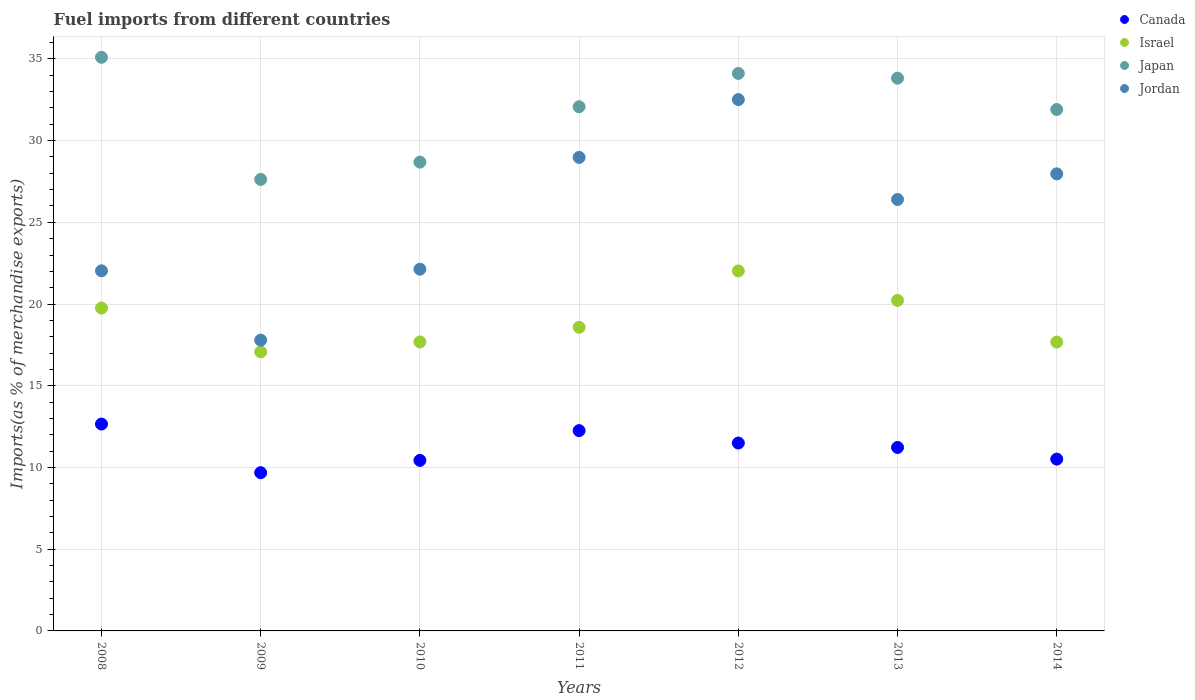How many different coloured dotlines are there?
Ensure brevity in your answer.  4. Is the number of dotlines equal to the number of legend labels?
Give a very brief answer. Yes. What is the percentage of imports to different countries in Japan in 2010?
Offer a very short reply. 28.68. Across all years, what is the maximum percentage of imports to different countries in Jordan?
Offer a terse response. 32.51. Across all years, what is the minimum percentage of imports to different countries in Japan?
Your response must be concise. 27.63. What is the total percentage of imports to different countries in Canada in the graph?
Provide a succinct answer. 78.27. What is the difference between the percentage of imports to different countries in Canada in 2008 and that in 2011?
Offer a terse response. 0.4. What is the difference between the percentage of imports to different countries in Jordan in 2011 and the percentage of imports to different countries in Canada in 2009?
Give a very brief answer. 19.29. What is the average percentage of imports to different countries in Jordan per year?
Your answer should be compact. 25.4. In the year 2012, what is the difference between the percentage of imports to different countries in Canada and percentage of imports to different countries in Israel?
Make the answer very short. -10.53. In how many years, is the percentage of imports to different countries in Canada greater than 23 %?
Provide a short and direct response. 0. What is the ratio of the percentage of imports to different countries in Canada in 2010 to that in 2014?
Provide a short and direct response. 0.99. Is the percentage of imports to different countries in Israel in 2009 less than that in 2013?
Provide a short and direct response. Yes. Is the difference between the percentage of imports to different countries in Canada in 2008 and 2014 greater than the difference between the percentage of imports to different countries in Israel in 2008 and 2014?
Offer a terse response. Yes. What is the difference between the highest and the second highest percentage of imports to different countries in Jordan?
Offer a very short reply. 3.54. What is the difference between the highest and the lowest percentage of imports to different countries in Canada?
Offer a very short reply. 2.97. In how many years, is the percentage of imports to different countries in Japan greater than the average percentage of imports to different countries in Japan taken over all years?
Give a very brief answer. 5. Is it the case that in every year, the sum of the percentage of imports to different countries in Israel and percentage of imports to different countries in Jordan  is greater than the sum of percentage of imports to different countries in Canada and percentage of imports to different countries in Japan?
Your answer should be compact. No. Is it the case that in every year, the sum of the percentage of imports to different countries in Japan and percentage of imports to different countries in Canada  is greater than the percentage of imports to different countries in Israel?
Make the answer very short. Yes. Does the percentage of imports to different countries in Japan monotonically increase over the years?
Make the answer very short. No. How many years are there in the graph?
Your answer should be compact. 7. What is the title of the graph?
Your response must be concise. Fuel imports from different countries. Does "Russian Federation" appear as one of the legend labels in the graph?
Your response must be concise. No. What is the label or title of the X-axis?
Keep it short and to the point. Years. What is the label or title of the Y-axis?
Make the answer very short. Imports(as % of merchandise exports). What is the Imports(as % of merchandise exports) of Canada in 2008?
Provide a succinct answer. 12.66. What is the Imports(as % of merchandise exports) of Israel in 2008?
Provide a succinct answer. 19.76. What is the Imports(as % of merchandise exports) of Japan in 2008?
Offer a very short reply. 35.1. What is the Imports(as % of merchandise exports) in Jordan in 2008?
Give a very brief answer. 22.03. What is the Imports(as % of merchandise exports) in Canada in 2009?
Keep it short and to the point. 9.68. What is the Imports(as % of merchandise exports) of Israel in 2009?
Give a very brief answer. 17.07. What is the Imports(as % of merchandise exports) of Japan in 2009?
Offer a terse response. 27.63. What is the Imports(as % of merchandise exports) in Jordan in 2009?
Your answer should be compact. 17.79. What is the Imports(as % of merchandise exports) in Canada in 2010?
Ensure brevity in your answer.  10.43. What is the Imports(as % of merchandise exports) of Israel in 2010?
Your answer should be very brief. 17.68. What is the Imports(as % of merchandise exports) of Japan in 2010?
Offer a very short reply. 28.68. What is the Imports(as % of merchandise exports) in Jordan in 2010?
Keep it short and to the point. 22.13. What is the Imports(as % of merchandise exports) in Canada in 2011?
Offer a very short reply. 12.26. What is the Imports(as % of merchandise exports) of Israel in 2011?
Make the answer very short. 18.58. What is the Imports(as % of merchandise exports) of Japan in 2011?
Your response must be concise. 32.07. What is the Imports(as % of merchandise exports) in Jordan in 2011?
Your answer should be very brief. 28.97. What is the Imports(as % of merchandise exports) in Canada in 2012?
Provide a short and direct response. 11.5. What is the Imports(as % of merchandise exports) in Israel in 2012?
Your response must be concise. 22.03. What is the Imports(as % of merchandise exports) in Japan in 2012?
Offer a very short reply. 34.11. What is the Imports(as % of merchandise exports) in Jordan in 2012?
Give a very brief answer. 32.51. What is the Imports(as % of merchandise exports) of Canada in 2013?
Keep it short and to the point. 11.23. What is the Imports(as % of merchandise exports) of Israel in 2013?
Your response must be concise. 20.22. What is the Imports(as % of merchandise exports) in Japan in 2013?
Provide a short and direct response. 33.82. What is the Imports(as % of merchandise exports) in Jordan in 2013?
Provide a succinct answer. 26.4. What is the Imports(as % of merchandise exports) of Canada in 2014?
Your answer should be very brief. 10.51. What is the Imports(as % of merchandise exports) of Israel in 2014?
Your response must be concise. 17.67. What is the Imports(as % of merchandise exports) in Japan in 2014?
Provide a short and direct response. 31.9. What is the Imports(as % of merchandise exports) in Jordan in 2014?
Ensure brevity in your answer.  27.97. Across all years, what is the maximum Imports(as % of merchandise exports) of Canada?
Your answer should be compact. 12.66. Across all years, what is the maximum Imports(as % of merchandise exports) of Israel?
Your response must be concise. 22.03. Across all years, what is the maximum Imports(as % of merchandise exports) in Japan?
Offer a very short reply. 35.1. Across all years, what is the maximum Imports(as % of merchandise exports) in Jordan?
Offer a very short reply. 32.51. Across all years, what is the minimum Imports(as % of merchandise exports) of Canada?
Make the answer very short. 9.68. Across all years, what is the minimum Imports(as % of merchandise exports) in Israel?
Offer a very short reply. 17.07. Across all years, what is the minimum Imports(as % of merchandise exports) of Japan?
Provide a succinct answer. 27.63. Across all years, what is the minimum Imports(as % of merchandise exports) of Jordan?
Offer a very short reply. 17.79. What is the total Imports(as % of merchandise exports) in Canada in the graph?
Your response must be concise. 78.27. What is the total Imports(as % of merchandise exports) of Israel in the graph?
Ensure brevity in your answer.  133.02. What is the total Imports(as % of merchandise exports) of Japan in the graph?
Provide a succinct answer. 223.31. What is the total Imports(as % of merchandise exports) in Jordan in the graph?
Keep it short and to the point. 177.81. What is the difference between the Imports(as % of merchandise exports) of Canada in 2008 and that in 2009?
Make the answer very short. 2.97. What is the difference between the Imports(as % of merchandise exports) of Israel in 2008 and that in 2009?
Provide a succinct answer. 2.68. What is the difference between the Imports(as % of merchandise exports) in Japan in 2008 and that in 2009?
Keep it short and to the point. 7.47. What is the difference between the Imports(as % of merchandise exports) in Jordan in 2008 and that in 2009?
Keep it short and to the point. 4.24. What is the difference between the Imports(as % of merchandise exports) in Canada in 2008 and that in 2010?
Offer a terse response. 2.22. What is the difference between the Imports(as % of merchandise exports) in Israel in 2008 and that in 2010?
Make the answer very short. 2.07. What is the difference between the Imports(as % of merchandise exports) in Japan in 2008 and that in 2010?
Offer a very short reply. 6.41. What is the difference between the Imports(as % of merchandise exports) in Jordan in 2008 and that in 2010?
Provide a short and direct response. -0.1. What is the difference between the Imports(as % of merchandise exports) of Canada in 2008 and that in 2011?
Ensure brevity in your answer.  0.4. What is the difference between the Imports(as % of merchandise exports) of Israel in 2008 and that in 2011?
Your response must be concise. 1.18. What is the difference between the Imports(as % of merchandise exports) of Japan in 2008 and that in 2011?
Offer a terse response. 3.02. What is the difference between the Imports(as % of merchandise exports) in Jordan in 2008 and that in 2011?
Your answer should be compact. -6.94. What is the difference between the Imports(as % of merchandise exports) of Canada in 2008 and that in 2012?
Keep it short and to the point. 1.16. What is the difference between the Imports(as % of merchandise exports) in Israel in 2008 and that in 2012?
Give a very brief answer. -2.27. What is the difference between the Imports(as % of merchandise exports) of Japan in 2008 and that in 2012?
Provide a short and direct response. 0.98. What is the difference between the Imports(as % of merchandise exports) of Jordan in 2008 and that in 2012?
Give a very brief answer. -10.48. What is the difference between the Imports(as % of merchandise exports) in Canada in 2008 and that in 2013?
Make the answer very short. 1.43. What is the difference between the Imports(as % of merchandise exports) of Israel in 2008 and that in 2013?
Offer a very short reply. -0.47. What is the difference between the Imports(as % of merchandise exports) in Japan in 2008 and that in 2013?
Offer a terse response. 1.27. What is the difference between the Imports(as % of merchandise exports) of Jordan in 2008 and that in 2013?
Make the answer very short. -4.36. What is the difference between the Imports(as % of merchandise exports) of Canada in 2008 and that in 2014?
Ensure brevity in your answer.  2.14. What is the difference between the Imports(as % of merchandise exports) of Israel in 2008 and that in 2014?
Your answer should be very brief. 2.08. What is the difference between the Imports(as % of merchandise exports) in Japan in 2008 and that in 2014?
Provide a short and direct response. 3.19. What is the difference between the Imports(as % of merchandise exports) of Jordan in 2008 and that in 2014?
Provide a succinct answer. -5.93. What is the difference between the Imports(as % of merchandise exports) in Canada in 2009 and that in 2010?
Provide a succinct answer. -0.75. What is the difference between the Imports(as % of merchandise exports) of Israel in 2009 and that in 2010?
Offer a very short reply. -0.61. What is the difference between the Imports(as % of merchandise exports) in Japan in 2009 and that in 2010?
Your answer should be very brief. -1.06. What is the difference between the Imports(as % of merchandise exports) of Jordan in 2009 and that in 2010?
Make the answer very short. -4.34. What is the difference between the Imports(as % of merchandise exports) of Canada in 2009 and that in 2011?
Give a very brief answer. -2.57. What is the difference between the Imports(as % of merchandise exports) in Israel in 2009 and that in 2011?
Offer a terse response. -1.5. What is the difference between the Imports(as % of merchandise exports) of Japan in 2009 and that in 2011?
Offer a terse response. -4.45. What is the difference between the Imports(as % of merchandise exports) of Jordan in 2009 and that in 2011?
Your answer should be compact. -11.18. What is the difference between the Imports(as % of merchandise exports) of Canada in 2009 and that in 2012?
Provide a short and direct response. -1.81. What is the difference between the Imports(as % of merchandise exports) of Israel in 2009 and that in 2012?
Your response must be concise. -4.95. What is the difference between the Imports(as % of merchandise exports) of Japan in 2009 and that in 2012?
Your response must be concise. -6.49. What is the difference between the Imports(as % of merchandise exports) of Jordan in 2009 and that in 2012?
Give a very brief answer. -14.72. What is the difference between the Imports(as % of merchandise exports) in Canada in 2009 and that in 2013?
Keep it short and to the point. -1.54. What is the difference between the Imports(as % of merchandise exports) in Israel in 2009 and that in 2013?
Offer a very short reply. -3.15. What is the difference between the Imports(as % of merchandise exports) in Japan in 2009 and that in 2013?
Your answer should be compact. -6.2. What is the difference between the Imports(as % of merchandise exports) in Jordan in 2009 and that in 2013?
Ensure brevity in your answer.  -8.61. What is the difference between the Imports(as % of merchandise exports) in Canada in 2009 and that in 2014?
Make the answer very short. -0.83. What is the difference between the Imports(as % of merchandise exports) of Japan in 2009 and that in 2014?
Offer a terse response. -4.28. What is the difference between the Imports(as % of merchandise exports) of Jordan in 2009 and that in 2014?
Provide a short and direct response. -10.17. What is the difference between the Imports(as % of merchandise exports) of Canada in 2010 and that in 2011?
Provide a short and direct response. -1.82. What is the difference between the Imports(as % of merchandise exports) in Israel in 2010 and that in 2011?
Your response must be concise. -0.9. What is the difference between the Imports(as % of merchandise exports) in Japan in 2010 and that in 2011?
Keep it short and to the point. -3.39. What is the difference between the Imports(as % of merchandise exports) of Jordan in 2010 and that in 2011?
Give a very brief answer. -6.84. What is the difference between the Imports(as % of merchandise exports) in Canada in 2010 and that in 2012?
Provide a short and direct response. -1.06. What is the difference between the Imports(as % of merchandise exports) of Israel in 2010 and that in 2012?
Make the answer very short. -4.34. What is the difference between the Imports(as % of merchandise exports) in Japan in 2010 and that in 2012?
Provide a succinct answer. -5.43. What is the difference between the Imports(as % of merchandise exports) of Jordan in 2010 and that in 2012?
Your answer should be very brief. -10.38. What is the difference between the Imports(as % of merchandise exports) of Canada in 2010 and that in 2013?
Provide a short and direct response. -0.79. What is the difference between the Imports(as % of merchandise exports) in Israel in 2010 and that in 2013?
Your response must be concise. -2.54. What is the difference between the Imports(as % of merchandise exports) in Japan in 2010 and that in 2013?
Offer a very short reply. -5.14. What is the difference between the Imports(as % of merchandise exports) in Jordan in 2010 and that in 2013?
Your answer should be very brief. -4.27. What is the difference between the Imports(as % of merchandise exports) of Canada in 2010 and that in 2014?
Offer a terse response. -0.08. What is the difference between the Imports(as % of merchandise exports) in Israel in 2010 and that in 2014?
Make the answer very short. 0.01. What is the difference between the Imports(as % of merchandise exports) in Japan in 2010 and that in 2014?
Offer a very short reply. -3.22. What is the difference between the Imports(as % of merchandise exports) of Jordan in 2010 and that in 2014?
Make the answer very short. -5.83. What is the difference between the Imports(as % of merchandise exports) of Canada in 2011 and that in 2012?
Your response must be concise. 0.76. What is the difference between the Imports(as % of merchandise exports) in Israel in 2011 and that in 2012?
Provide a short and direct response. -3.45. What is the difference between the Imports(as % of merchandise exports) in Japan in 2011 and that in 2012?
Your response must be concise. -2.04. What is the difference between the Imports(as % of merchandise exports) of Jordan in 2011 and that in 2012?
Ensure brevity in your answer.  -3.54. What is the difference between the Imports(as % of merchandise exports) in Canada in 2011 and that in 2013?
Give a very brief answer. 1.03. What is the difference between the Imports(as % of merchandise exports) of Israel in 2011 and that in 2013?
Give a very brief answer. -1.64. What is the difference between the Imports(as % of merchandise exports) in Japan in 2011 and that in 2013?
Keep it short and to the point. -1.75. What is the difference between the Imports(as % of merchandise exports) of Jordan in 2011 and that in 2013?
Offer a very short reply. 2.57. What is the difference between the Imports(as % of merchandise exports) in Canada in 2011 and that in 2014?
Keep it short and to the point. 1.74. What is the difference between the Imports(as % of merchandise exports) in Israel in 2011 and that in 2014?
Your answer should be very brief. 0.9. What is the difference between the Imports(as % of merchandise exports) of Japan in 2011 and that in 2014?
Keep it short and to the point. 0.17. What is the difference between the Imports(as % of merchandise exports) in Jordan in 2011 and that in 2014?
Ensure brevity in your answer.  1.01. What is the difference between the Imports(as % of merchandise exports) of Canada in 2012 and that in 2013?
Your answer should be very brief. 0.27. What is the difference between the Imports(as % of merchandise exports) in Israel in 2012 and that in 2013?
Provide a succinct answer. 1.8. What is the difference between the Imports(as % of merchandise exports) in Japan in 2012 and that in 2013?
Ensure brevity in your answer.  0.29. What is the difference between the Imports(as % of merchandise exports) in Jordan in 2012 and that in 2013?
Your response must be concise. 6.11. What is the difference between the Imports(as % of merchandise exports) of Canada in 2012 and that in 2014?
Make the answer very short. 0.98. What is the difference between the Imports(as % of merchandise exports) of Israel in 2012 and that in 2014?
Offer a terse response. 4.35. What is the difference between the Imports(as % of merchandise exports) in Japan in 2012 and that in 2014?
Provide a short and direct response. 2.21. What is the difference between the Imports(as % of merchandise exports) in Jordan in 2012 and that in 2014?
Keep it short and to the point. 4.55. What is the difference between the Imports(as % of merchandise exports) in Canada in 2013 and that in 2014?
Offer a very short reply. 0.71. What is the difference between the Imports(as % of merchandise exports) in Israel in 2013 and that in 2014?
Give a very brief answer. 2.55. What is the difference between the Imports(as % of merchandise exports) in Japan in 2013 and that in 2014?
Ensure brevity in your answer.  1.92. What is the difference between the Imports(as % of merchandise exports) in Jordan in 2013 and that in 2014?
Provide a short and direct response. -1.57. What is the difference between the Imports(as % of merchandise exports) of Canada in 2008 and the Imports(as % of merchandise exports) of Israel in 2009?
Provide a short and direct response. -4.42. What is the difference between the Imports(as % of merchandise exports) in Canada in 2008 and the Imports(as % of merchandise exports) in Japan in 2009?
Your answer should be compact. -14.97. What is the difference between the Imports(as % of merchandise exports) of Canada in 2008 and the Imports(as % of merchandise exports) of Jordan in 2009?
Your answer should be compact. -5.14. What is the difference between the Imports(as % of merchandise exports) in Israel in 2008 and the Imports(as % of merchandise exports) in Japan in 2009?
Provide a short and direct response. -7.87. What is the difference between the Imports(as % of merchandise exports) of Israel in 2008 and the Imports(as % of merchandise exports) of Jordan in 2009?
Your answer should be compact. 1.96. What is the difference between the Imports(as % of merchandise exports) of Japan in 2008 and the Imports(as % of merchandise exports) of Jordan in 2009?
Your answer should be very brief. 17.3. What is the difference between the Imports(as % of merchandise exports) of Canada in 2008 and the Imports(as % of merchandise exports) of Israel in 2010?
Offer a terse response. -5.02. What is the difference between the Imports(as % of merchandise exports) of Canada in 2008 and the Imports(as % of merchandise exports) of Japan in 2010?
Offer a very short reply. -16.03. What is the difference between the Imports(as % of merchandise exports) in Canada in 2008 and the Imports(as % of merchandise exports) in Jordan in 2010?
Make the answer very short. -9.48. What is the difference between the Imports(as % of merchandise exports) of Israel in 2008 and the Imports(as % of merchandise exports) of Japan in 2010?
Provide a short and direct response. -8.93. What is the difference between the Imports(as % of merchandise exports) in Israel in 2008 and the Imports(as % of merchandise exports) in Jordan in 2010?
Your answer should be compact. -2.38. What is the difference between the Imports(as % of merchandise exports) of Japan in 2008 and the Imports(as % of merchandise exports) of Jordan in 2010?
Your answer should be compact. 12.96. What is the difference between the Imports(as % of merchandise exports) of Canada in 2008 and the Imports(as % of merchandise exports) of Israel in 2011?
Give a very brief answer. -5.92. What is the difference between the Imports(as % of merchandise exports) of Canada in 2008 and the Imports(as % of merchandise exports) of Japan in 2011?
Provide a short and direct response. -19.42. What is the difference between the Imports(as % of merchandise exports) in Canada in 2008 and the Imports(as % of merchandise exports) in Jordan in 2011?
Offer a terse response. -16.31. What is the difference between the Imports(as % of merchandise exports) of Israel in 2008 and the Imports(as % of merchandise exports) of Japan in 2011?
Your response must be concise. -12.32. What is the difference between the Imports(as % of merchandise exports) of Israel in 2008 and the Imports(as % of merchandise exports) of Jordan in 2011?
Make the answer very short. -9.22. What is the difference between the Imports(as % of merchandise exports) in Japan in 2008 and the Imports(as % of merchandise exports) in Jordan in 2011?
Your answer should be very brief. 6.12. What is the difference between the Imports(as % of merchandise exports) of Canada in 2008 and the Imports(as % of merchandise exports) of Israel in 2012?
Ensure brevity in your answer.  -9.37. What is the difference between the Imports(as % of merchandise exports) of Canada in 2008 and the Imports(as % of merchandise exports) of Japan in 2012?
Give a very brief answer. -21.45. What is the difference between the Imports(as % of merchandise exports) in Canada in 2008 and the Imports(as % of merchandise exports) in Jordan in 2012?
Give a very brief answer. -19.85. What is the difference between the Imports(as % of merchandise exports) of Israel in 2008 and the Imports(as % of merchandise exports) of Japan in 2012?
Offer a terse response. -14.36. What is the difference between the Imports(as % of merchandise exports) in Israel in 2008 and the Imports(as % of merchandise exports) in Jordan in 2012?
Offer a very short reply. -12.76. What is the difference between the Imports(as % of merchandise exports) in Japan in 2008 and the Imports(as % of merchandise exports) in Jordan in 2012?
Offer a very short reply. 2.58. What is the difference between the Imports(as % of merchandise exports) in Canada in 2008 and the Imports(as % of merchandise exports) in Israel in 2013?
Your answer should be compact. -7.57. What is the difference between the Imports(as % of merchandise exports) of Canada in 2008 and the Imports(as % of merchandise exports) of Japan in 2013?
Give a very brief answer. -21.16. What is the difference between the Imports(as % of merchandise exports) of Canada in 2008 and the Imports(as % of merchandise exports) of Jordan in 2013?
Provide a succinct answer. -13.74. What is the difference between the Imports(as % of merchandise exports) in Israel in 2008 and the Imports(as % of merchandise exports) in Japan in 2013?
Make the answer very short. -14.07. What is the difference between the Imports(as % of merchandise exports) in Israel in 2008 and the Imports(as % of merchandise exports) in Jordan in 2013?
Your answer should be very brief. -6.64. What is the difference between the Imports(as % of merchandise exports) in Japan in 2008 and the Imports(as % of merchandise exports) in Jordan in 2013?
Make the answer very short. 8.7. What is the difference between the Imports(as % of merchandise exports) of Canada in 2008 and the Imports(as % of merchandise exports) of Israel in 2014?
Keep it short and to the point. -5.02. What is the difference between the Imports(as % of merchandise exports) of Canada in 2008 and the Imports(as % of merchandise exports) of Japan in 2014?
Make the answer very short. -19.25. What is the difference between the Imports(as % of merchandise exports) in Canada in 2008 and the Imports(as % of merchandise exports) in Jordan in 2014?
Make the answer very short. -15.31. What is the difference between the Imports(as % of merchandise exports) of Israel in 2008 and the Imports(as % of merchandise exports) of Japan in 2014?
Offer a terse response. -12.15. What is the difference between the Imports(as % of merchandise exports) in Israel in 2008 and the Imports(as % of merchandise exports) in Jordan in 2014?
Your answer should be very brief. -8.21. What is the difference between the Imports(as % of merchandise exports) in Japan in 2008 and the Imports(as % of merchandise exports) in Jordan in 2014?
Give a very brief answer. 7.13. What is the difference between the Imports(as % of merchandise exports) in Canada in 2009 and the Imports(as % of merchandise exports) in Israel in 2010?
Your answer should be compact. -8. What is the difference between the Imports(as % of merchandise exports) of Canada in 2009 and the Imports(as % of merchandise exports) of Japan in 2010?
Offer a terse response. -19. What is the difference between the Imports(as % of merchandise exports) of Canada in 2009 and the Imports(as % of merchandise exports) of Jordan in 2010?
Give a very brief answer. -12.45. What is the difference between the Imports(as % of merchandise exports) of Israel in 2009 and the Imports(as % of merchandise exports) of Japan in 2010?
Your response must be concise. -11.61. What is the difference between the Imports(as % of merchandise exports) of Israel in 2009 and the Imports(as % of merchandise exports) of Jordan in 2010?
Your answer should be very brief. -5.06. What is the difference between the Imports(as % of merchandise exports) of Japan in 2009 and the Imports(as % of merchandise exports) of Jordan in 2010?
Provide a short and direct response. 5.49. What is the difference between the Imports(as % of merchandise exports) in Canada in 2009 and the Imports(as % of merchandise exports) in Israel in 2011?
Provide a succinct answer. -8.9. What is the difference between the Imports(as % of merchandise exports) in Canada in 2009 and the Imports(as % of merchandise exports) in Japan in 2011?
Offer a terse response. -22.39. What is the difference between the Imports(as % of merchandise exports) in Canada in 2009 and the Imports(as % of merchandise exports) in Jordan in 2011?
Your answer should be very brief. -19.29. What is the difference between the Imports(as % of merchandise exports) in Israel in 2009 and the Imports(as % of merchandise exports) in Japan in 2011?
Your response must be concise. -15. What is the difference between the Imports(as % of merchandise exports) of Israel in 2009 and the Imports(as % of merchandise exports) of Jordan in 2011?
Give a very brief answer. -11.9. What is the difference between the Imports(as % of merchandise exports) in Japan in 2009 and the Imports(as % of merchandise exports) in Jordan in 2011?
Ensure brevity in your answer.  -1.35. What is the difference between the Imports(as % of merchandise exports) in Canada in 2009 and the Imports(as % of merchandise exports) in Israel in 2012?
Keep it short and to the point. -12.34. What is the difference between the Imports(as % of merchandise exports) of Canada in 2009 and the Imports(as % of merchandise exports) of Japan in 2012?
Your answer should be very brief. -24.43. What is the difference between the Imports(as % of merchandise exports) of Canada in 2009 and the Imports(as % of merchandise exports) of Jordan in 2012?
Provide a succinct answer. -22.83. What is the difference between the Imports(as % of merchandise exports) in Israel in 2009 and the Imports(as % of merchandise exports) in Japan in 2012?
Provide a short and direct response. -17.04. What is the difference between the Imports(as % of merchandise exports) in Israel in 2009 and the Imports(as % of merchandise exports) in Jordan in 2012?
Offer a very short reply. -15.44. What is the difference between the Imports(as % of merchandise exports) of Japan in 2009 and the Imports(as % of merchandise exports) of Jordan in 2012?
Your response must be concise. -4.89. What is the difference between the Imports(as % of merchandise exports) in Canada in 2009 and the Imports(as % of merchandise exports) in Israel in 2013?
Your answer should be very brief. -10.54. What is the difference between the Imports(as % of merchandise exports) in Canada in 2009 and the Imports(as % of merchandise exports) in Japan in 2013?
Make the answer very short. -24.14. What is the difference between the Imports(as % of merchandise exports) in Canada in 2009 and the Imports(as % of merchandise exports) in Jordan in 2013?
Offer a very short reply. -16.72. What is the difference between the Imports(as % of merchandise exports) in Israel in 2009 and the Imports(as % of merchandise exports) in Japan in 2013?
Give a very brief answer. -16.75. What is the difference between the Imports(as % of merchandise exports) of Israel in 2009 and the Imports(as % of merchandise exports) of Jordan in 2013?
Provide a short and direct response. -9.32. What is the difference between the Imports(as % of merchandise exports) of Japan in 2009 and the Imports(as % of merchandise exports) of Jordan in 2013?
Your answer should be compact. 1.23. What is the difference between the Imports(as % of merchandise exports) of Canada in 2009 and the Imports(as % of merchandise exports) of Israel in 2014?
Give a very brief answer. -7.99. What is the difference between the Imports(as % of merchandise exports) of Canada in 2009 and the Imports(as % of merchandise exports) of Japan in 2014?
Provide a succinct answer. -22.22. What is the difference between the Imports(as % of merchandise exports) of Canada in 2009 and the Imports(as % of merchandise exports) of Jordan in 2014?
Make the answer very short. -18.28. What is the difference between the Imports(as % of merchandise exports) in Israel in 2009 and the Imports(as % of merchandise exports) in Japan in 2014?
Offer a very short reply. -14.83. What is the difference between the Imports(as % of merchandise exports) of Israel in 2009 and the Imports(as % of merchandise exports) of Jordan in 2014?
Offer a very short reply. -10.89. What is the difference between the Imports(as % of merchandise exports) in Japan in 2009 and the Imports(as % of merchandise exports) in Jordan in 2014?
Give a very brief answer. -0.34. What is the difference between the Imports(as % of merchandise exports) in Canada in 2010 and the Imports(as % of merchandise exports) in Israel in 2011?
Your answer should be compact. -8.14. What is the difference between the Imports(as % of merchandise exports) of Canada in 2010 and the Imports(as % of merchandise exports) of Japan in 2011?
Keep it short and to the point. -21.64. What is the difference between the Imports(as % of merchandise exports) of Canada in 2010 and the Imports(as % of merchandise exports) of Jordan in 2011?
Offer a terse response. -18.54. What is the difference between the Imports(as % of merchandise exports) in Israel in 2010 and the Imports(as % of merchandise exports) in Japan in 2011?
Your answer should be very brief. -14.39. What is the difference between the Imports(as % of merchandise exports) in Israel in 2010 and the Imports(as % of merchandise exports) in Jordan in 2011?
Provide a succinct answer. -11.29. What is the difference between the Imports(as % of merchandise exports) of Japan in 2010 and the Imports(as % of merchandise exports) of Jordan in 2011?
Your answer should be compact. -0.29. What is the difference between the Imports(as % of merchandise exports) in Canada in 2010 and the Imports(as % of merchandise exports) in Israel in 2012?
Offer a terse response. -11.59. What is the difference between the Imports(as % of merchandise exports) in Canada in 2010 and the Imports(as % of merchandise exports) in Japan in 2012?
Your answer should be compact. -23.68. What is the difference between the Imports(as % of merchandise exports) in Canada in 2010 and the Imports(as % of merchandise exports) in Jordan in 2012?
Your answer should be compact. -22.08. What is the difference between the Imports(as % of merchandise exports) of Israel in 2010 and the Imports(as % of merchandise exports) of Japan in 2012?
Offer a terse response. -16.43. What is the difference between the Imports(as % of merchandise exports) of Israel in 2010 and the Imports(as % of merchandise exports) of Jordan in 2012?
Offer a terse response. -14.83. What is the difference between the Imports(as % of merchandise exports) of Japan in 2010 and the Imports(as % of merchandise exports) of Jordan in 2012?
Offer a terse response. -3.83. What is the difference between the Imports(as % of merchandise exports) of Canada in 2010 and the Imports(as % of merchandise exports) of Israel in 2013?
Give a very brief answer. -9.79. What is the difference between the Imports(as % of merchandise exports) of Canada in 2010 and the Imports(as % of merchandise exports) of Japan in 2013?
Give a very brief answer. -23.39. What is the difference between the Imports(as % of merchandise exports) in Canada in 2010 and the Imports(as % of merchandise exports) in Jordan in 2013?
Your answer should be very brief. -15.96. What is the difference between the Imports(as % of merchandise exports) in Israel in 2010 and the Imports(as % of merchandise exports) in Japan in 2013?
Your response must be concise. -16.14. What is the difference between the Imports(as % of merchandise exports) of Israel in 2010 and the Imports(as % of merchandise exports) of Jordan in 2013?
Provide a short and direct response. -8.72. What is the difference between the Imports(as % of merchandise exports) of Japan in 2010 and the Imports(as % of merchandise exports) of Jordan in 2013?
Make the answer very short. 2.29. What is the difference between the Imports(as % of merchandise exports) of Canada in 2010 and the Imports(as % of merchandise exports) of Israel in 2014?
Provide a short and direct response. -7.24. What is the difference between the Imports(as % of merchandise exports) in Canada in 2010 and the Imports(as % of merchandise exports) in Japan in 2014?
Offer a very short reply. -21.47. What is the difference between the Imports(as % of merchandise exports) of Canada in 2010 and the Imports(as % of merchandise exports) of Jordan in 2014?
Your answer should be very brief. -17.53. What is the difference between the Imports(as % of merchandise exports) of Israel in 2010 and the Imports(as % of merchandise exports) of Japan in 2014?
Give a very brief answer. -14.22. What is the difference between the Imports(as % of merchandise exports) in Israel in 2010 and the Imports(as % of merchandise exports) in Jordan in 2014?
Provide a succinct answer. -10.28. What is the difference between the Imports(as % of merchandise exports) in Japan in 2010 and the Imports(as % of merchandise exports) in Jordan in 2014?
Provide a succinct answer. 0.72. What is the difference between the Imports(as % of merchandise exports) in Canada in 2011 and the Imports(as % of merchandise exports) in Israel in 2012?
Provide a short and direct response. -9.77. What is the difference between the Imports(as % of merchandise exports) of Canada in 2011 and the Imports(as % of merchandise exports) of Japan in 2012?
Provide a succinct answer. -21.86. What is the difference between the Imports(as % of merchandise exports) of Canada in 2011 and the Imports(as % of merchandise exports) of Jordan in 2012?
Provide a short and direct response. -20.26. What is the difference between the Imports(as % of merchandise exports) in Israel in 2011 and the Imports(as % of merchandise exports) in Japan in 2012?
Offer a terse response. -15.53. What is the difference between the Imports(as % of merchandise exports) in Israel in 2011 and the Imports(as % of merchandise exports) in Jordan in 2012?
Offer a terse response. -13.93. What is the difference between the Imports(as % of merchandise exports) of Japan in 2011 and the Imports(as % of merchandise exports) of Jordan in 2012?
Keep it short and to the point. -0.44. What is the difference between the Imports(as % of merchandise exports) in Canada in 2011 and the Imports(as % of merchandise exports) in Israel in 2013?
Make the answer very short. -7.97. What is the difference between the Imports(as % of merchandise exports) of Canada in 2011 and the Imports(as % of merchandise exports) of Japan in 2013?
Your answer should be very brief. -21.57. What is the difference between the Imports(as % of merchandise exports) in Canada in 2011 and the Imports(as % of merchandise exports) in Jordan in 2013?
Provide a succinct answer. -14.14. What is the difference between the Imports(as % of merchandise exports) of Israel in 2011 and the Imports(as % of merchandise exports) of Japan in 2013?
Make the answer very short. -15.24. What is the difference between the Imports(as % of merchandise exports) of Israel in 2011 and the Imports(as % of merchandise exports) of Jordan in 2013?
Your answer should be very brief. -7.82. What is the difference between the Imports(as % of merchandise exports) in Japan in 2011 and the Imports(as % of merchandise exports) in Jordan in 2013?
Provide a succinct answer. 5.68. What is the difference between the Imports(as % of merchandise exports) in Canada in 2011 and the Imports(as % of merchandise exports) in Israel in 2014?
Provide a short and direct response. -5.42. What is the difference between the Imports(as % of merchandise exports) in Canada in 2011 and the Imports(as % of merchandise exports) in Japan in 2014?
Your answer should be compact. -19.65. What is the difference between the Imports(as % of merchandise exports) in Canada in 2011 and the Imports(as % of merchandise exports) in Jordan in 2014?
Offer a very short reply. -15.71. What is the difference between the Imports(as % of merchandise exports) in Israel in 2011 and the Imports(as % of merchandise exports) in Japan in 2014?
Your response must be concise. -13.32. What is the difference between the Imports(as % of merchandise exports) of Israel in 2011 and the Imports(as % of merchandise exports) of Jordan in 2014?
Offer a terse response. -9.39. What is the difference between the Imports(as % of merchandise exports) of Japan in 2011 and the Imports(as % of merchandise exports) of Jordan in 2014?
Keep it short and to the point. 4.11. What is the difference between the Imports(as % of merchandise exports) of Canada in 2012 and the Imports(as % of merchandise exports) of Israel in 2013?
Your answer should be very brief. -8.73. What is the difference between the Imports(as % of merchandise exports) of Canada in 2012 and the Imports(as % of merchandise exports) of Japan in 2013?
Keep it short and to the point. -22.33. What is the difference between the Imports(as % of merchandise exports) in Canada in 2012 and the Imports(as % of merchandise exports) in Jordan in 2013?
Your response must be concise. -14.9. What is the difference between the Imports(as % of merchandise exports) in Israel in 2012 and the Imports(as % of merchandise exports) in Japan in 2013?
Ensure brevity in your answer.  -11.79. What is the difference between the Imports(as % of merchandise exports) in Israel in 2012 and the Imports(as % of merchandise exports) in Jordan in 2013?
Your answer should be very brief. -4.37. What is the difference between the Imports(as % of merchandise exports) of Japan in 2012 and the Imports(as % of merchandise exports) of Jordan in 2013?
Ensure brevity in your answer.  7.71. What is the difference between the Imports(as % of merchandise exports) in Canada in 2012 and the Imports(as % of merchandise exports) in Israel in 2014?
Provide a short and direct response. -6.18. What is the difference between the Imports(as % of merchandise exports) in Canada in 2012 and the Imports(as % of merchandise exports) in Japan in 2014?
Offer a very short reply. -20.41. What is the difference between the Imports(as % of merchandise exports) of Canada in 2012 and the Imports(as % of merchandise exports) of Jordan in 2014?
Your answer should be compact. -16.47. What is the difference between the Imports(as % of merchandise exports) of Israel in 2012 and the Imports(as % of merchandise exports) of Japan in 2014?
Offer a terse response. -9.88. What is the difference between the Imports(as % of merchandise exports) of Israel in 2012 and the Imports(as % of merchandise exports) of Jordan in 2014?
Offer a terse response. -5.94. What is the difference between the Imports(as % of merchandise exports) in Japan in 2012 and the Imports(as % of merchandise exports) in Jordan in 2014?
Offer a terse response. 6.14. What is the difference between the Imports(as % of merchandise exports) in Canada in 2013 and the Imports(as % of merchandise exports) in Israel in 2014?
Offer a terse response. -6.45. What is the difference between the Imports(as % of merchandise exports) in Canada in 2013 and the Imports(as % of merchandise exports) in Japan in 2014?
Offer a very short reply. -20.68. What is the difference between the Imports(as % of merchandise exports) in Canada in 2013 and the Imports(as % of merchandise exports) in Jordan in 2014?
Offer a terse response. -16.74. What is the difference between the Imports(as % of merchandise exports) in Israel in 2013 and the Imports(as % of merchandise exports) in Japan in 2014?
Give a very brief answer. -11.68. What is the difference between the Imports(as % of merchandise exports) of Israel in 2013 and the Imports(as % of merchandise exports) of Jordan in 2014?
Offer a terse response. -7.74. What is the difference between the Imports(as % of merchandise exports) in Japan in 2013 and the Imports(as % of merchandise exports) in Jordan in 2014?
Make the answer very short. 5.85. What is the average Imports(as % of merchandise exports) in Canada per year?
Make the answer very short. 11.18. What is the average Imports(as % of merchandise exports) of Israel per year?
Offer a very short reply. 19. What is the average Imports(as % of merchandise exports) in Japan per year?
Give a very brief answer. 31.9. What is the average Imports(as % of merchandise exports) in Jordan per year?
Give a very brief answer. 25.4. In the year 2008, what is the difference between the Imports(as % of merchandise exports) of Canada and Imports(as % of merchandise exports) of Israel?
Offer a very short reply. -7.1. In the year 2008, what is the difference between the Imports(as % of merchandise exports) in Canada and Imports(as % of merchandise exports) in Japan?
Ensure brevity in your answer.  -22.44. In the year 2008, what is the difference between the Imports(as % of merchandise exports) of Canada and Imports(as % of merchandise exports) of Jordan?
Offer a terse response. -9.38. In the year 2008, what is the difference between the Imports(as % of merchandise exports) in Israel and Imports(as % of merchandise exports) in Japan?
Ensure brevity in your answer.  -15.34. In the year 2008, what is the difference between the Imports(as % of merchandise exports) in Israel and Imports(as % of merchandise exports) in Jordan?
Keep it short and to the point. -2.28. In the year 2008, what is the difference between the Imports(as % of merchandise exports) of Japan and Imports(as % of merchandise exports) of Jordan?
Your answer should be very brief. 13.06. In the year 2009, what is the difference between the Imports(as % of merchandise exports) in Canada and Imports(as % of merchandise exports) in Israel?
Provide a short and direct response. -7.39. In the year 2009, what is the difference between the Imports(as % of merchandise exports) in Canada and Imports(as % of merchandise exports) in Japan?
Your answer should be compact. -17.94. In the year 2009, what is the difference between the Imports(as % of merchandise exports) in Canada and Imports(as % of merchandise exports) in Jordan?
Your response must be concise. -8.11. In the year 2009, what is the difference between the Imports(as % of merchandise exports) in Israel and Imports(as % of merchandise exports) in Japan?
Make the answer very short. -10.55. In the year 2009, what is the difference between the Imports(as % of merchandise exports) of Israel and Imports(as % of merchandise exports) of Jordan?
Provide a succinct answer. -0.72. In the year 2009, what is the difference between the Imports(as % of merchandise exports) of Japan and Imports(as % of merchandise exports) of Jordan?
Your answer should be very brief. 9.83. In the year 2010, what is the difference between the Imports(as % of merchandise exports) in Canada and Imports(as % of merchandise exports) in Israel?
Your answer should be compact. -7.25. In the year 2010, what is the difference between the Imports(as % of merchandise exports) of Canada and Imports(as % of merchandise exports) of Japan?
Give a very brief answer. -18.25. In the year 2010, what is the difference between the Imports(as % of merchandise exports) of Canada and Imports(as % of merchandise exports) of Jordan?
Give a very brief answer. -11.7. In the year 2010, what is the difference between the Imports(as % of merchandise exports) in Israel and Imports(as % of merchandise exports) in Japan?
Ensure brevity in your answer.  -11. In the year 2010, what is the difference between the Imports(as % of merchandise exports) in Israel and Imports(as % of merchandise exports) in Jordan?
Your answer should be compact. -4.45. In the year 2010, what is the difference between the Imports(as % of merchandise exports) in Japan and Imports(as % of merchandise exports) in Jordan?
Your response must be concise. 6.55. In the year 2011, what is the difference between the Imports(as % of merchandise exports) of Canada and Imports(as % of merchandise exports) of Israel?
Your response must be concise. -6.32. In the year 2011, what is the difference between the Imports(as % of merchandise exports) of Canada and Imports(as % of merchandise exports) of Japan?
Your response must be concise. -19.82. In the year 2011, what is the difference between the Imports(as % of merchandise exports) in Canada and Imports(as % of merchandise exports) in Jordan?
Give a very brief answer. -16.72. In the year 2011, what is the difference between the Imports(as % of merchandise exports) of Israel and Imports(as % of merchandise exports) of Japan?
Your answer should be compact. -13.49. In the year 2011, what is the difference between the Imports(as % of merchandise exports) in Israel and Imports(as % of merchandise exports) in Jordan?
Provide a succinct answer. -10.39. In the year 2011, what is the difference between the Imports(as % of merchandise exports) of Japan and Imports(as % of merchandise exports) of Jordan?
Your answer should be very brief. 3.1. In the year 2012, what is the difference between the Imports(as % of merchandise exports) in Canada and Imports(as % of merchandise exports) in Israel?
Offer a terse response. -10.53. In the year 2012, what is the difference between the Imports(as % of merchandise exports) of Canada and Imports(as % of merchandise exports) of Japan?
Keep it short and to the point. -22.62. In the year 2012, what is the difference between the Imports(as % of merchandise exports) in Canada and Imports(as % of merchandise exports) in Jordan?
Keep it short and to the point. -21.02. In the year 2012, what is the difference between the Imports(as % of merchandise exports) of Israel and Imports(as % of merchandise exports) of Japan?
Offer a terse response. -12.08. In the year 2012, what is the difference between the Imports(as % of merchandise exports) of Israel and Imports(as % of merchandise exports) of Jordan?
Provide a short and direct response. -10.48. In the year 2012, what is the difference between the Imports(as % of merchandise exports) in Japan and Imports(as % of merchandise exports) in Jordan?
Provide a succinct answer. 1.6. In the year 2013, what is the difference between the Imports(as % of merchandise exports) in Canada and Imports(as % of merchandise exports) in Israel?
Provide a short and direct response. -9. In the year 2013, what is the difference between the Imports(as % of merchandise exports) in Canada and Imports(as % of merchandise exports) in Japan?
Provide a succinct answer. -22.6. In the year 2013, what is the difference between the Imports(as % of merchandise exports) in Canada and Imports(as % of merchandise exports) in Jordan?
Ensure brevity in your answer.  -15.17. In the year 2013, what is the difference between the Imports(as % of merchandise exports) of Israel and Imports(as % of merchandise exports) of Japan?
Your answer should be compact. -13.6. In the year 2013, what is the difference between the Imports(as % of merchandise exports) in Israel and Imports(as % of merchandise exports) in Jordan?
Ensure brevity in your answer.  -6.18. In the year 2013, what is the difference between the Imports(as % of merchandise exports) in Japan and Imports(as % of merchandise exports) in Jordan?
Your answer should be very brief. 7.42. In the year 2014, what is the difference between the Imports(as % of merchandise exports) of Canada and Imports(as % of merchandise exports) of Israel?
Your answer should be very brief. -7.16. In the year 2014, what is the difference between the Imports(as % of merchandise exports) of Canada and Imports(as % of merchandise exports) of Japan?
Provide a short and direct response. -21.39. In the year 2014, what is the difference between the Imports(as % of merchandise exports) in Canada and Imports(as % of merchandise exports) in Jordan?
Ensure brevity in your answer.  -17.45. In the year 2014, what is the difference between the Imports(as % of merchandise exports) in Israel and Imports(as % of merchandise exports) in Japan?
Make the answer very short. -14.23. In the year 2014, what is the difference between the Imports(as % of merchandise exports) in Israel and Imports(as % of merchandise exports) in Jordan?
Make the answer very short. -10.29. In the year 2014, what is the difference between the Imports(as % of merchandise exports) of Japan and Imports(as % of merchandise exports) of Jordan?
Offer a very short reply. 3.94. What is the ratio of the Imports(as % of merchandise exports) in Canada in 2008 to that in 2009?
Give a very brief answer. 1.31. What is the ratio of the Imports(as % of merchandise exports) in Israel in 2008 to that in 2009?
Keep it short and to the point. 1.16. What is the ratio of the Imports(as % of merchandise exports) of Japan in 2008 to that in 2009?
Make the answer very short. 1.27. What is the ratio of the Imports(as % of merchandise exports) in Jordan in 2008 to that in 2009?
Provide a short and direct response. 1.24. What is the ratio of the Imports(as % of merchandise exports) in Canada in 2008 to that in 2010?
Your response must be concise. 1.21. What is the ratio of the Imports(as % of merchandise exports) of Israel in 2008 to that in 2010?
Provide a short and direct response. 1.12. What is the ratio of the Imports(as % of merchandise exports) of Japan in 2008 to that in 2010?
Give a very brief answer. 1.22. What is the ratio of the Imports(as % of merchandise exports) of Canada in 2008 to that in 2011?
Offer a very short reply. 1.03. What is the ratio of the Imports(as % of merchandise exports) of Israel in 2008 to that in 2011?
Ensure brevity in your answer.  1.06. What is the ratio of the Imports(as % of merchandise exports) in Japan in 2008 to that in 2011?
Provide a short and direct response. 1.09. What is the ratio of the Imports(as % of merchandise exports) in Jordan in 2008 to that in 2011?
Provide a short and direct response. 0.76. What is the ratio of the Imports(as % of merchandise exports) of Canada in 2008 to that in 2012?
Provide a succinct answer. 1.1. What is the ratio of the Imports(as % of merchandise exports) of Israel in 2008 to that in 2012?
Give a very brief answer. 0.9. What is the ratio of the Imports(as % of merchandise exports) in Japan in 2008 to that in 2012?
Make the answer very short. 1.03. What is the ratio of the Imports(as % of merchandise exports) in Jordan in 2008 to that in 2012?
Keep it short and to the point. 0.68. What is the ratio of the Imports(as % of merchandise exports) of Canada in 2008 to that in 2013?
Provide a succinct answer. 1.13. What is the ratio of the Imports(as % of merchandise exports) of Israel in 2008 to that in 2013?
Make the answer very short. 0.98. What is the ratio of the Imports(as % of merchandise exports) of Japan in 2008 to that in 2013?
Your answer should be very brief. 1.04. What is the ratio of the Imports(as % of merchandise exports) of Jordan in 2008 to that in 2013?
Your response must be concise. 0.83. What is the ratio of the Imports(as % of merchandise exports) in Canada in 2008 to that in 2014?
Give a very brief answer. 1.2. What is the ratio of the Imports(as % of merchandise exports) in Israel in 2008 to that in 2014?
Offer a terse response. 1.12. What is the ratio of the Imports(as % of merchandise exports) in Japan in 2008 to that in 2014?
Your response must be concise. 1.1. What is the ratio of the Imports(as % of merchandise exports) of Jordan in 2008 to that in 2014?
Make the answer very short. 0.79. What is the ratio of the Imports(as % of merchandise exports) in Canada in 2009 to that in 2010?
Make the answer very short. 0.93. What is the ratio of the Imports(as % of merchandise exports) in Israel in 2009 to that in 2010?
Offer a terse response. 0.97. What is the ratio of the Imports(as % of merchandise exports) in Japan in 2009 to that in 2010?
Ensure brevity in your answer.  0.96. What is the ratio of the Imports(as % of merchandise exports) of Jordan in 2009 to that in 2010?
Your response must be concise. 0.8. What is the ratio of the Imports(as % of merchandise exports) in Canada in 2009 to that in 2011?
Your answer should be very brief. 0.79. What is the ratio of the Imports(as % of merchandise exports) of Israel in 2009 to that in 2011?
Your answer should be compact. 0.92. What is the ratio of the Imports(as % of merchandise exports) of Japan in 2009 to that in 2011?
Your answer should be compact. 0.86. What is the ratio of the Imports(as % of merchandise exports) of Jordan in 2009 to that in 2011?
Your answer should be very brief. 0.61. What is the ratio of the Imports(as % of merchandise exports) of Canada in 2009 to that in 2012?
Your answer should be very brief. 0.84. What is the ratio of the Imports(as % of merchandise exports) in Israel in 2009 to that in 2012?
Ensure brevity in your answer.  0.78. What is the ratio of the Imports(as % of merchandise exports) in Japan in 2009 to that in 2012?
Offer a terse response. 0.81. What is the ratio of the Imports(as % of merchandise exports) of Jordan in 2009 to that in 2012?
Keep it short and to the point. 0.55. What is the ratio of the Imports(as % of merchandise exports) in Canada in 2009 to that in 2013?
Give a very brief answer. 0.86. What is the ratio of the Imports(as % of merchandise exports) in Israel in 2009 to that in 2013?
Provide a succinct answer. 0.84. What is the ratio of the Imports(as % of merchandise exports) in Japan in 2009 to that in 2013?
Your response must be concise. 0.82. What is the ratio of the Imports(as % of merchandise exports) in Jordan in 2009 to that in 2013?
Give a very brief answer. 0.67. What is the ratio of the Imports(as % of merchandise exports) in Canada in 2009 to that in 2014?
Your answer should be very brief. 0.92. What is the ratio of the Imports(as % of merchandise exports) in Israel in 2009 to that in 2014?
Your response must be concise. 0.97. What is the ratio of the Imports(as % of merchandise exports) in Japan in 2009 to that in 2014?
Provide a succinct answer. 0.87. What is the ratio of the Imports(as % of merchandise exports) in Jordan in 2009 to that in 2014?
Make the answer very short. 0.64. What is the ratio of the Imports(as % of merchandise exports) of Canada in 2010 to that in 2011?
Provide a short and direct response. 0.85. What is the ratio of the Imports(as % of merchandise exports) in Israel in 2010 to that in 2011?
Offer a terse response. 0.95. What is the ratio of the Imports(as % of merchandise exports) of Japan in 2010 to that in 2011?
Keep it short and to the point. 0.89. What is the ratio of the Imports(as % of merchandise exports) of Jordan in 2010 to that in 2011?
Keep it short and to the point. 0.76. What is the ratio of the Imports(as % of merchandise exports) of Canada in 2010 to that in 2012?
Your answer should be compact. 0.91. What is the ratio of the Imports(as % of merchandise exports) of Israel in 2010 to that in 2012?
Your answer should be very brief. 0.8. What is the ratio of the Imports(as % of merchandise exports) in Japan in 2010 to that in 2012?
Keep it short and to the point. 0.84. What is the ratio of the Imports(as % of merchandise exports) of Jordan in 2010 to that in 2012?
Your answer should be very brief. 0.68. What is the ratio of the Imports(as % of merchandise exports) of Canada in 2010 to that in 2013?
Your answer should be very brief. 0.93. What is the ratio of the Imports(as % of merchandise exports) in Israel in 2010 to that in 2013?
Offer a very short reply. 0.87. What is the ratio of the Imports(as % of merchandise exports) in Japan in 2010 to that in 2013?
Keep it short and to the point. 0.85. What is the ratio of the Imports(as % of merchandise exports) in Jordan in 2010 to that in 2013?
Give a very brief answer. 0.84. What is the ratio of the Imports(as % of merchandise exports) of Israel in 2010 to that in 2014?
Your answer should be compact. 1. What is the ratio of the Imports(as % of merchandise exports) in Japan in 2010 to that in 2014?
Provide a short and direct response. 0.9. What is the ratio of the Imports(as % of merchandise exports) of Jordan in 2010 to that in 2014?
Keep it short and to the point. 0.79. What is the ratio of the Imports(as % of merchandise exports) of Canada in 2011 to that in 2012?
Offer a terse response. 1.07. What is the ratio of the Imports(as % of merchandise exports) in Israel in 2011 to that in 2012?
Give a very brief answer. 0.84. What is the ratio of the Imports(as % of merchandise exports) of Japan in 2011 to that in 2012?
Your answer should be very brief. 0.94. What is the ratio of the Imports(as % of merchandise exports) in Jordan in 2011 to that in 2012?
Offer a very short reply. 0.89. What is the ratio of the Imports(as % of merchandise exports) of Canada in 2011 to that in 2013?
Offer a terse response. 1.09. What is the ratio of the Imports(as % of merchandise exports) of Israel in 2011 to that in 2013?
Offer a very short reply. 0.92. What is the ratio of the Imports(as % of merchandise exports) in Japan in 2011 to that in 2013?
Ensure brevity in your answer.  0.95. What is the ratio of the Imports(as % of merchandise exports) of Jordan in 2011 to that in 2013?
Give a very brief answer. 1.1. What is the ratio of the Imports(as % of merchandise exports) of Canada in 2011 to that in 2014?
Your response must be concise. 1.17. What is the ratio of the Imports(as % of merchandise exports) in Israel in 2011 to that in 2014?
Provide a short and direct response. 1.05. What is the ratio of the Imports(as % of merchandise exports) in Japan in 2011 to that in 2014?
Make the answer very short. 1.01. What is the ratio of the Imports(as % of merchandise exports) of Jordan in 2011 to that in 2014?
Offer a terse response. 1.04. What is the ratio of the Imports(as % of merchandise exports) of Canada in 2012 to that in 2013?
Offer a terse response. 1.02. What is the ratio of the Imports(as % of merchandise exports) of Israel in 2012 to that in 2013?
Your answer should be compact. 1.09. What is the ratio of the Imports(as % of merchandise exports) in Japan in 2012 to that in 2013?
Give a very brief answer. 1.01. What is the ratio of the Imports(as % of merchandise exports) of Jordan in 2012 to that in 2013?
Provide a short and direct response. 1.23. What is the ratio of the Imports(as % of merchandise exports) of Canada in 2012 to that in 2014?
Your answer should be compact. 1.09. What is the ratio of the Imports(as % of merchandise exports) of Israel in 2012 to that in 2014?
Make the answer very short. 1.25. What is the ratio of the Imports(as % of merchandise exports) in Japan in 2012 to that in 2014?
Give a very brief answer. 1.07. What is the ratio of the Imports(as % of merchandise exports) of Jordan in 2012 to that in 2014?
Make the answer very short. 1.16. What is the ratio of the Imports(as % of merchandise exports) of Canada in 2013 to that in 2014?
Keep it short and to the point. 1.07. What is the ratio of the Imports(as % of merchandise exports) in Israel in 2013 to that in 2014?
Keep it short and to the point. 1.14. What is the ratio of the Imports(as % of merchandise exports) of Japan in 2013 to that in 2014?
Give a very brief answer. 1.06. What is the ratio of the Imports(as % of merchandise exports) in Jordan in 2013 to that in 2014?
Your answer should be very brief. 0.94. What is the difference between the highest and the second highest Imports(as % of merchandise exports) of Canada?
Offer a very short reply. 0.4. What is the difference between the highest and the second highest Imports(as % of merchandise exports) in Israel?
Provide a short and direct response. 1.8. What is the difference between the highest and the second highest Imports(as % of merchandise exports) of Japan?
Make the answer very short. 0.98. What is the difference between the highest and the second highest Imports(as % of merchandise exports) of Jordan?
Provide a succinct answer. 3.54. What is the difference between the highest and the lowest Imports(as % of merchandise exports) in Canada?
Ensure brevity in your answer.  2.97. What is the difference between the highest and the lowest Imports(as % of merchandise exports) of Israel?
Make the answer very short. 4.95. What is the difference between the highest and the lowest Imports(as % of merchandise exports) of Japan?
Offer a very short reply. 7.47. What is the difference between the highest and the lowest Imports(as % of merchandise exports) in Jordan?
Offer a terse response. 14.72. 